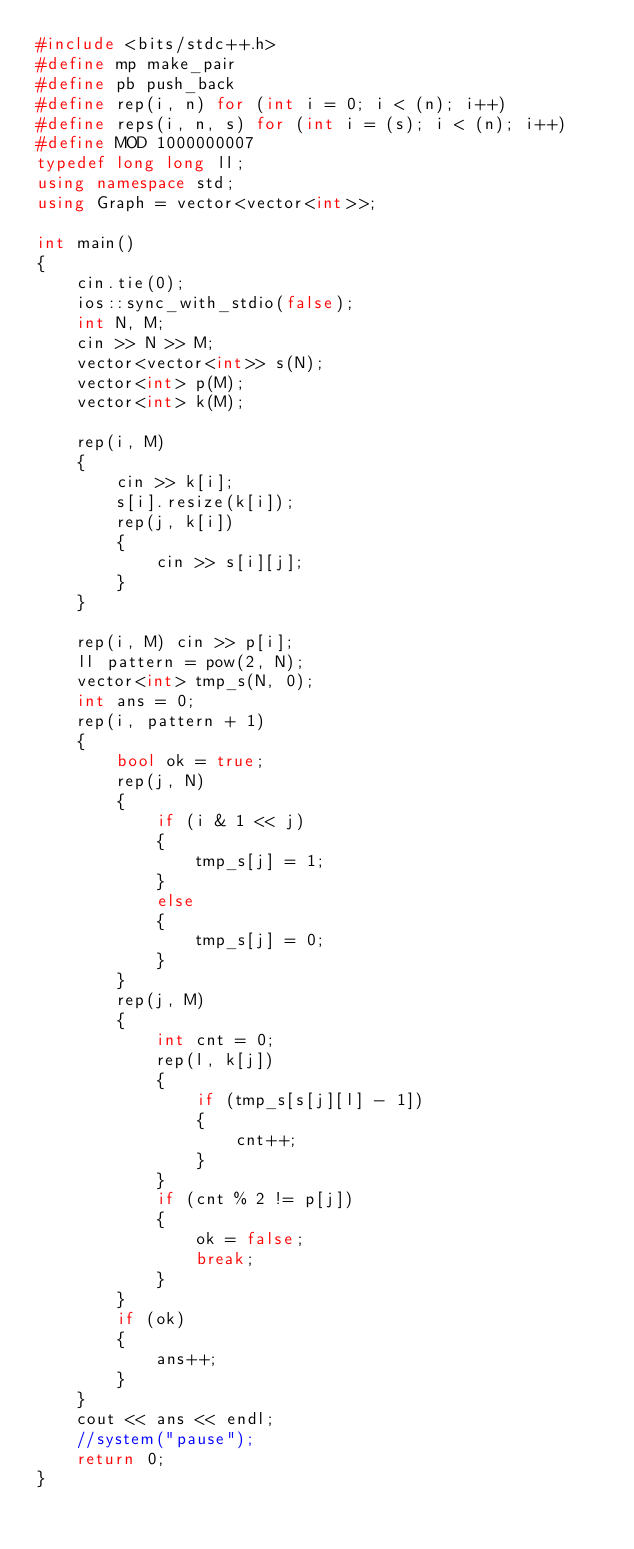Convert code to text. <code><loc_0><loc_0><loc_500><loc_500><_C++_>#include <bits/stdc++.h>
#define mp make_pair
#define pb push_back
#define rep(i, n) for (int i = 0; i < (n); i++)
#define reps(i, n, s) for (int i = (s); i < (n); i++)
#define MOD 1000000007
typedef long long ll;
using namespace std;
using Graph = vector<vector<int>>;

int main()
{
    cin.tie(0);
    ios::sync_with_stdio(false);
    int N, M;
    cin >> N >> M;
    vector<vector<int>> s(N);
    vector<int> p(M);
    vector<int> k(M);

    rep(i, M)
    {
        cin >> k[i];
        s[i].resize(k[i]);
        rep(j, k[i])
        {
            cin >> s[i][j];
        }
    }

    rep(i, M) cin >> p[i];
    ll pattern = pow(2, N);
    vector<int> tmp_s(N, 0);
    int ans = 0;
    rep(i, pattern + 1)
    {
        bool ok = true;
        rep(j, N)
        {
            if (i & 1 << j)
            {
                tmp_s[j] = 1;
            }
            else
            {
                tmp_s[j] = 0;
            }
        }
        rep(j, M)
        {
            int cnt = 0;
            rep(l, k[j])
            {
                if (tmp_s[s[j][l] - 1])
                {
                    cnt++;
                }
            }
            if (cnt % 2 != p[j])
            {
                ok = false;
                break;
            }
        }
        if (ok)
        {
            ans++;
        }
    }
    cout << ans << endl;
    //system("pause");
    return 0;
}</code> 